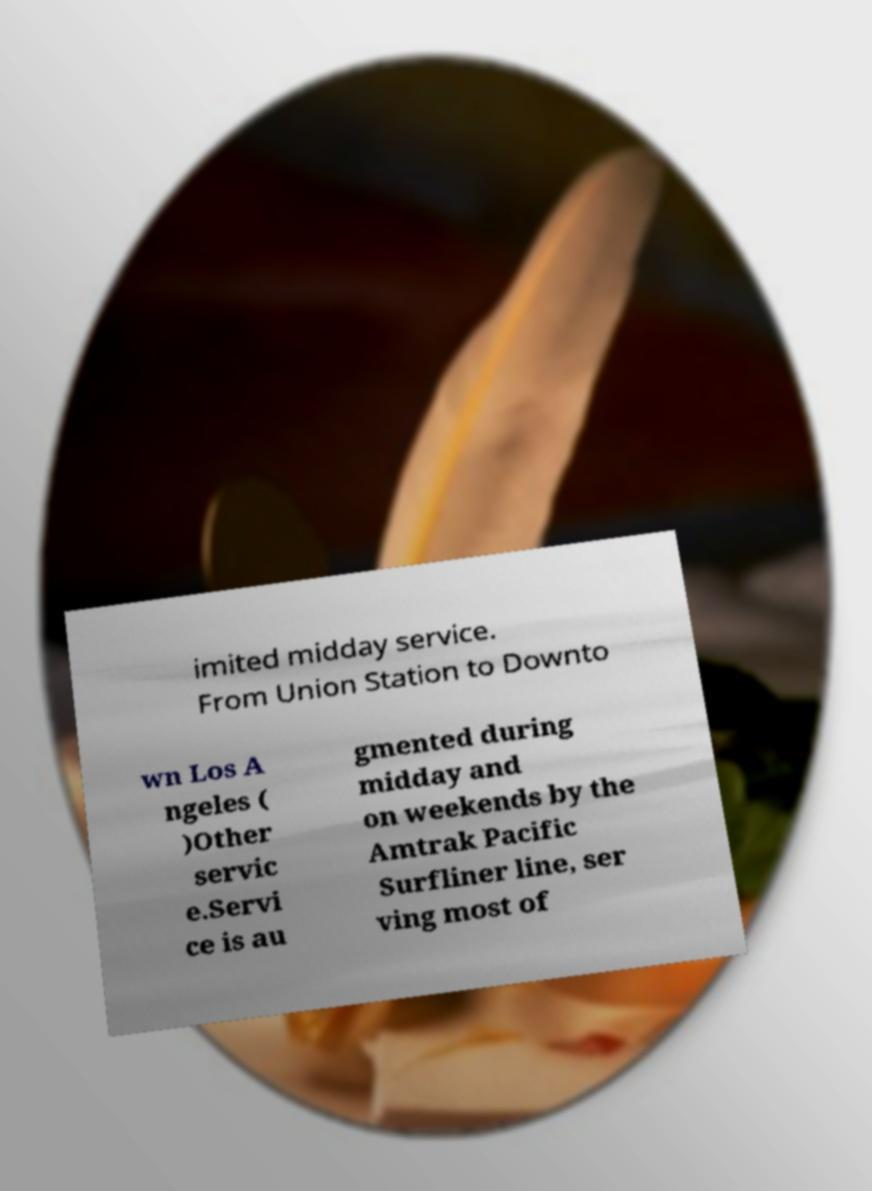What messages or text are displayed in this image? I need them in a readable, typed format. imited midday service. From Union Station to Downto wn Los A ngeles ( )Other servic e.Servi ce is au gmented during midday and on weekends by the Amtrak Pacific Surfliner line, ser ving most of 